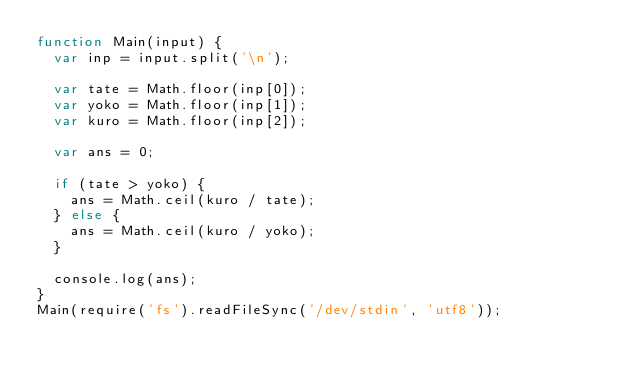Convert code to text. <code><loc_0><loc_0><loc_500><loc_500><_JavaScript_>function Main(input) {
  var inp = input.split('\n');

  var tate = Math.floor(inp[0]);
  var yoko = Math.floor(inp[1]);
  var kuro = Math.floor(inp[2]);
  
  var ans = 0;
  
  if (tate > yoko) {
    ans = Math.ceil(kuro / tate);
  } else {
    ans = Math.ceil(kuro / yoko);
  }
  
  console.log(ans);
}
Main(require('fs').readFileSync('/dev/stdin', 'utf8'));</code> 